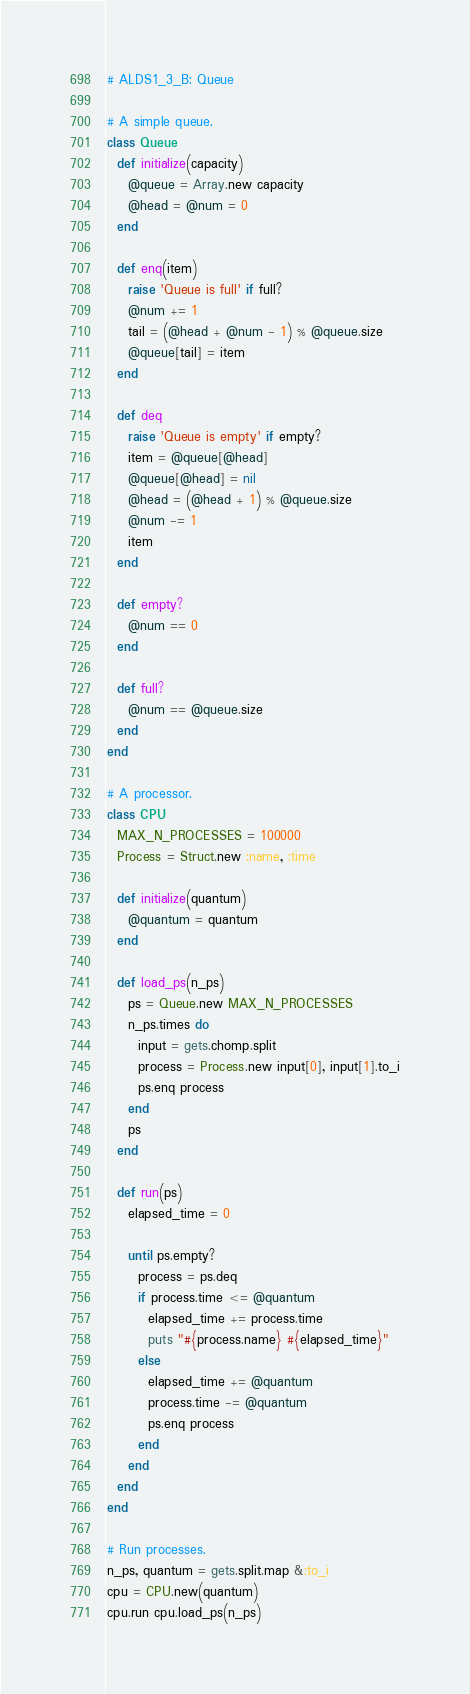Convert code to text. <code><loc_0><loc_0><loc_500><loc_500><_Ruby_># ALDS1_3_B: Queue

# A simple queue.
class Queue
  def initialize(capacity)
    @queue = Array.new capacity
    @head = @num = 0
  end

  def enq(item)
    raise 'Queue is full' if full?
    @num += 1
    tail = (@head + @num - 1) % @queue.size
    @queue[tail] = item
  end

  def deq
    raise 'Queue is empty' if empty?
    item = @queue[@head]
    @queue[@head] = nil
    @head = (@head + 1) % @queue.size
    @num -= 1
    item
  end

  def empty?
    @num == 0
  end

  def full?
    @num == @queue.size
  end
end

# A processor.
class CPU
  MAX_N_PROCESSES = 100000
  Process = Struct.new :name, :time

  def initialize(quantum)
    @quantum = quantum
  end

  def load_ps(n_ps)
    ps = Queue.new MAX_N_PROCESSES
    n_ps.times do
      input = gets.chomp.split
      process = Process.new input[0], input[1].to_i
      ps.enq process
    end
    ps
  end

  def run(ps)
    elapsed_time = 0

    until ps.empty?
      process = ps.deq
      if process.time <= @quantum
        elapsed_time += process.time
        puts "#{process.name} #{elapsed_time}"
      else
        elapsed_time += @quantum
        process.time -= @quantum
        ps.enq process
      end
    end
  end
end

# Run processes.
n_ps, quantum = gets.split.map &:to_i
cpu = CPU.new(quantum)
cpu.run cpu.load_ps(n_ps)</code> 